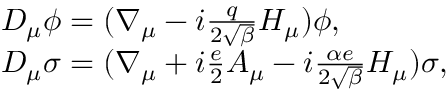<formula> <loc_0><loc_0><loc_500><loc_500>\begin{array} { l l } { { D _ { \mu } \phi = ( \nabla _ { \mu } - i \frac { q } { 2 \sqrt { \beta } } H _ { \mu } ) \phi , } } \\ { { D _ { \mu } \sigma = ( \nabla _ { \mu } + i \frac { e } { 2 } A _ { \mu } - i \frac { \alpha e } { 2 \sqrt { \beta } } H _ { \mu } ) \sigma , } } \end{array}</formula> 